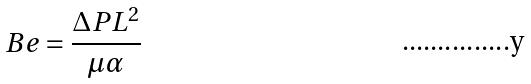Convert formula to latex. <formula><loc_0><loc_0><loc_500><loc_500>B e = \frac { \Delta P L ^ { 2 } } { \mu \alpha }</formula> 